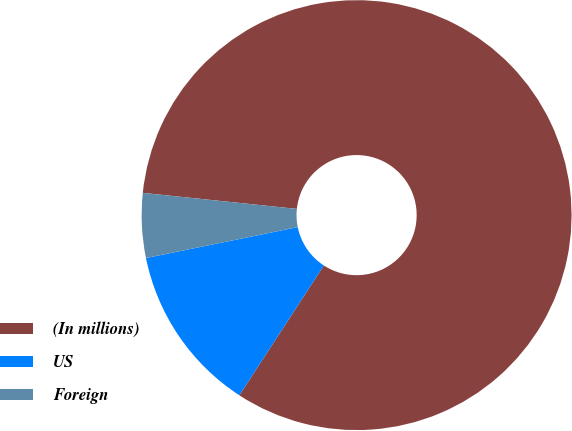<chart> <loc_0><loc_0><loc_500><loc_500><pie_chart><fcel>(In millions)<fcel>US<fcel>Foreign<nl><fcel>82.53%<fcel>12.62%<fcel>4.85%<nl></chart> 